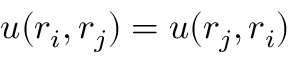<formula> <loc_0><loc_0><loc_500><loc_500>u ( r _ { i } , r _ { j } ) = u ( r _ { j } , r _ { i } )</formula> 